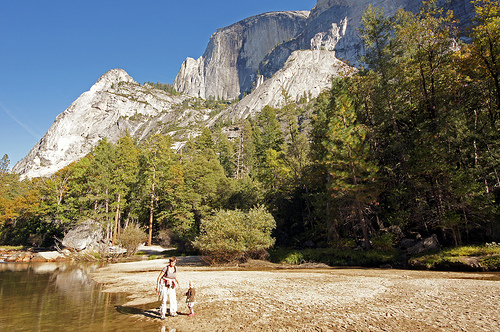<image>
Is there a trees under the mountain? Yes. The trees is positioned underneath the mountain, with the mountain above it in the vertical space. 